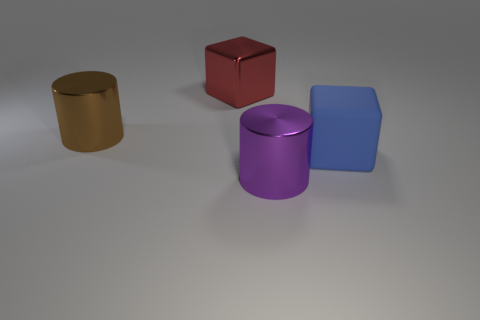Add 2 blue blocks. How many objects exist? 6 Add 2 big objects. How many big objects exist? 6 Subtract 1 brown cylinders. How many objects are left? 3 Subtract all blue blocks. Subtract all large cylinders. How many objects are left? 1 Add 3 large metal cubes. How many large metal cubes are left? 4 